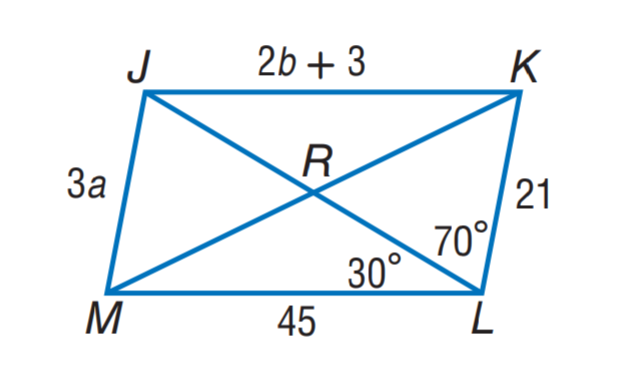Answer the mathemtical geometry problem and directly provide the correct option letter.
Question: Use parallelogram J K L M to find m \angle J M L.
Choices: A: 60 B: 70 C: 80 D: 90 C 